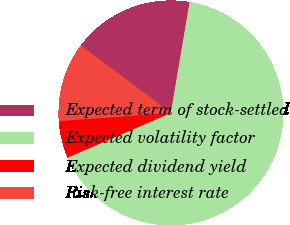<chart> <loc_0><loc_0><loc_500><loc_500><pie_chart><fcel>Expected term of stock-settled<fcel>Expected volatility factor<fcel>Expected dividend yield<fcel>Risk-free interest rate<nl><fcel>17.44%<fcel>65.84%<fcel>5.34%<fcel>11.38%<nl></chart> 